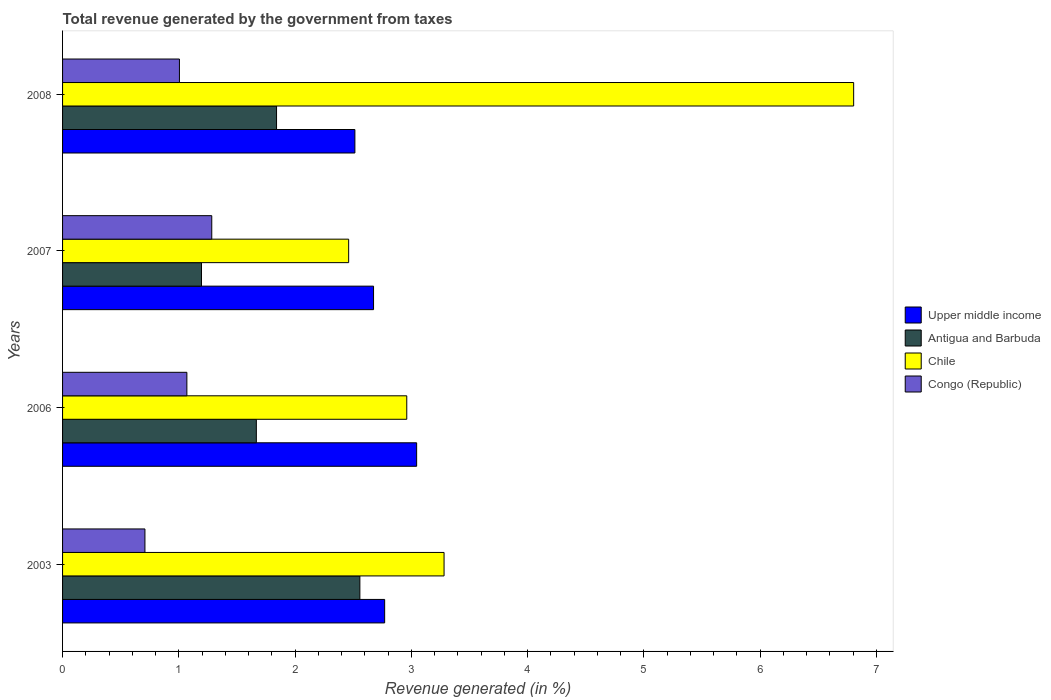How many different coloured bars are there?
Your response must be concise. 4. How many groups of bars are there?
Keep it short and to the point. 4. Are the number of bars on each tick of the Y-axis equal?
Offer a terse response. Yes. How many bars are there on the 3rd tick from the top?
Your response must be concise. 4. How many bars are there on the 3rd tick from the bottom?
Give a very brief answer. 4. What is the label of the 2nd group of bars from the top?
Ensure brevity in your answer.  2007. In how many cases, is the number of bars for a given year not equal to the number of legend labels?
Your response must be concise. 0. What is the total revenue generated in Congo (Republic) in 2006?
Your answer should be very brief. 1.07. Across all years, what is the maximum total revenue generated in Congo (Republic)?
Your answer should be very brief. 1.28. Across all years, what is the minimum total revenue generated in Chile?
Provide a succinct answer. 2.46. In which year was the total revenue generated in Upper middle income minimum?
Your response must be concise. 2008. What is the total total revenue generated in Chile in the graph?
Keep it short and to the point. 15.51. What is the difference between the total revenue generated in Chile in 2003 and that in 2007?
Make the answer very short. 0.82. What is the difference between the total revenue generated in Congo (Republic) in 2006 and the total revenue generated in Chile in 2003?
Ensure brevity in your answer.  -2.21. What is the average total revenue generated in Chile per year?
Offer a terse response. 3.88. In the year 2003, what is the difference between the total revenue generated in Antigua and Barbuda and total revenue generated in Congo (Republic)?
Provide a succinct answer. 1.85. In how many years, is the total revenue generated in Upper middle income greater than 4.8 %?
Offer a terse response. 0. What is the ratio of the total revenue generated in Antigua and Barbuda in 2007 to that in 2008?
Keep it short and to the point. 0.65. Is the total revenue generated in Congo (Republic) in 2006 less than that in 2007?
Offer a very short reply. Yes. Is the difference between the total revenue generated in Antigua and Barbuda in 2003 and 2007 greater than the difference between the total revenue generated in Congo (Republic) in 2003 and 2007?
Ensure brevity in your answer.  Yes. What is the difference between the highest and the second highest total revenue generated in Upper middle income?
Your answer should be compact. 0.28. What is the difference between the highest and the lowest total revenue generated in Upper middle income?
Your answer should be compact. 0.53. Is it the case that in every year, the sum of the total revenue generated in Antigua and Barbuda and total revenue generated in Upper middle income is greater than the sum of total revenue generated in Chile and total revenue generated in Congo (Republic)?
Provide a succinct answer. Yes. What does the 4th bar from the top in 2003 represents?
Provide a succinct answer. Upper middle income. What does the 1st bar from the bottom in 2007 represents?
Ensure brevity in your answer.  Upper middle income. Is it the case that in every year, the sum of the total revenue generated in Chile and total revenue generated in Antigua and Barbuda is greater than the total revenue generated in Congo (Republic)?
Your answer should be very brief. Yes. How many bars are there?
Offer a very short reply. 16. Are all the bars in the graph horizontal?
Keep it short and to the point. Yes. How many years are there in the graph?
Provide a succinct answer. 4. Are the values on the major ticks of X-axis written in scientific E-notation?
Offer a very short reply. No. Does the graph contain any zero values?
Your answer should be compact. No. Does the graph contain grids?
Ensure brevity in your answer.  No. How many legend labels are there?
Provide a short and direct response. 4. How are the legend labels stacked?
Your response must be concise. Vertical. What is the title of the graph?
Offer a terse response. Total revenue generated by the government from taxes. What is the label or title of the X-axis?
Make the answer very short. Revenue generated (in %). What is the label or title of the Y-axis?
Make the answer very short. Years. What is the Revenue generated (in %) of Upper middle income in 2003?
Your answer should be very brief. 2.77. What is the Revenue generated (in %) in Antigua and Barbuda in 2003?
Ensure brevity in your answer.  2.56. What is the Revenue generated (in %) of Chile in 2003?
Offer a terse response. 3.28. What is the Revenue generated (in %) of Congo (Republic) in 2003?
Provide a succinct answer. 0.71. What is the Revenue generated (in %) in Upper middle income in 2006?
Keep it short and to the point. 3.05. What is the Revenue generated (in %) of Antigua and Barbuda in 2006?
Offer a very short reply. 1.67. What is the Revenue generated (in %) in Chile in 2006?
Your response must be concise. 2.96. What is the Revenue generated (in %) in Congo (Republic) in 2006?
Provide a succinct answer. 1.07. What is the Revenue generated (in %) of Upper middle income in 2007?
Your answer should be compact. 2.68. What is the Revenue generated (in %) in Antigua and Barbuda in 2007?
Your response must be concise. 1.2. What is the Revenue generated (in %) in Chile in 2007?
Provide a succinct answer. 2.46. What is the Revenue generated (in %) in Congo (Republic) in 2007?
Your answer should be compact. 1.28. What is the Revenue generated (in %) of Upper middle income in 2008?
Keep it short and to the point. 2.51. What is the Revenue generated (in %) of Antigua and Barbuda in 2008?
Give a very brief answer. 1.84. What is the Revenue generated (in %) of Chile in 2008?
Give a very brief answer. 6.81. What is the Revenue generated (in %) of Congo (Republic) in 2008?
Provide a short and direct response. 1.01. Across all years, what is the maximum Revenue generated (in %) of Upper middle income?
Offer a very short reply. 3.05. Across all years, what is the maximum Revenue generated (in %) in Antigua and Barbuda?
Provide a short and direct response. 2.56. Across all years, what is the maximum Revenue generated (in %) in Chile?
Your response must be concise. 6.81. Across all years, what is the maximum Revenue generated (in %) of Congo (Republic)?
Offer a very short reply. 1.28. Across all years, what is the minimum Revenue generated (in %) of Upper middle income?
Your answer should be very brief. 2.51. Across all years, what is the minimum Revenue generated (in %) in Antigua and Barbuda?
Make the answer very short. 1.2. Across all years, what is the minimum Revenue generated (in %) in Chile?
Your answer should be very brief. 2.46. Across all years, what is the minimum Revenue generated (in %) of Congo (Republic)?
Ensure brevity in your answer.  0.71. What is the total Revenue generated (in %) in Upper middle income in the graph?
Offer a terse response. 11.01. What is the total Revenue generated (in %) of Antigua and Barbuda in the graph?
Make the answer very short. 7.26. What is the total Revenue generated (in %) of Chile in the graph?
Make the answer very short. 15.51. What is the total Revenue generated (in %) in Congo (Republic) in the graph?
Your answer should be very brief. 4.07. What is the difference between the Revenue generated (in %) of Upper middle income in 2003 and that in 2006?
Ensure brevity in your answer.  -0.28. What is the difference between the Revenue generated (in %) in Antigua and Barbuda in 2003 and that in 2006?
Offer a terse response. 0.89. What is the difference between the Revenue generated (in %) of Chile in 2003 and that in 2006?
Your answer should be compact. 0.32. What is the difference between the Revenue generated (in %) of Congo (Republic) in 2003 and that in 2006?
Give a very brief answer. -0.36. What is the difference between the Revenue generated (in %) in Upper middle income in 2003 and that in 2007?
Ensure brevity in your answer.  0.1. What is the difference between the Revenue generated (in %) of Antigua and Barbuda in 2003 and that in 2007?
Your answer should be very brief. 1.36. What is the difference between the Revenue generated (in %) in Chile in 2003 and that in 2007?
Keep it short and to the point. 0.82. What is the difference between the Revenue generated (in %) of Congo (Republic) in 2003 and that in 2007?
Keep it short and to the point. -0.57. What is the difference between the Revenue generated (in %) in Upper middle income in 2003 and that in 2008?
Offer a very short reply. 0.26. What is the difference between the Revenue generated (in %) in Antigua and Barbuda in 2003 and that in 2008?
Keep it short and to the point. 0.72. What is the difference between the Revenue generated (in %) in Chile in 2003 and that in 2008?
Your response must be concise. -3.52. What is the difference between the Revenue generated (in %) in Congo (Republic) in 2003 and that in 2008?
Keep it short and to the point. -0.3. What is the difference between the Revenue generated (in %) of Upper middle income in 2006 and that in 2007?
Your answer should be compact. 0.37. What is the difference between the Revenue generated (in %) of Antigua and Barbuda in 2006 and that in 2007?
Offer a terse response. 0.47. What is the difference between the Revenue generated (in %) of Chile in 2006 and that in 2007?
Offer a terse response. 0.5. What is the difference between the Revenue generated (in %) of Congo (Republic) in 2006 and that in 2007?
Your answer should be very brief. -0.21. What is the difference between the Revenue generated (in %) in Upper middle income in 2006 and that in 2008?
Your answer should be compact. 0.53. What is the difference between the Revenue generated (in %) in Antigua and Barbuda in 2006 and that in 2008?
Provide a short and direct response. -0.17. What is the difference between the Revenue generated (in %) in Chile in 2006 and that in 2008?
Keep it short and to the point. -3.84. What is the difference between the Revenue generated (in %) of Congo (Republic) in 2006 and that in 2008?
Your answer should be compact. 0.06. What is the difference between the Revenue generated (in %) of Upper middle income in 2007 and that in 2008?
Keep it short and to the point. 0.16. What is the difference between the Revenue generated (in %) of Antigua and Barbuda in 2007 and that in 2008?
Your answer should be very brief. -0.65. What is the difference between the Revenue generated (in %) of Chile in 2007 and that in 2008?
Offer a very short reply. -4.34. What is the difference between the Revenue generated (in %) of Congo (Republic) in 2007 and that in 2008?
Your response must be concise. 0.28. What is the difference between the Revenue generated (in %) of Upper middle income in 2003 and the Revenue generated (in %) of Antigua and Barbuda in 2006?
Provide a succinct answer. 1.1. What is the difference between the Revenue generated (in %) in Upper middle income in 2003 and the Revenue generated (in %) in Chile in 2006?
Give a very brief answer. -0.19. What is the difference between the Revenue generated (in %) in Upper middle income in 2003 and the Revenue generated (in %) in Congo (Republic) in 2006?
Keep it short and to the point. 1.7. What is the difference between the Revenue generated (in %) of Antigua and Barbuda in 2003 and the Revenue generated (in %) of Chile in 2006?
Provide a succinct answer. -0.4. What is the difference between the Revenue generated (in %) in Antigua and Barbuda in 2003 and the Revenue generated (in %) in Congo (Republic) in 2006?
Provide a succinct answer. 1.49. What is the difference between the Revenue generated (in %) of Chile in 2003 and the Revenue generated (in %) of Congo (Republic) in 2006?
Provide a succinct answer. 2.21. What is the difference between the Revenue generated (in %) of Upper middle income in 2003 and the Revenue generated (in %) of Antigua and Barbuda in 2007?
Give a very brief answer. 1.58. What is the difference between the Revenue generated (in %) in Upper middle income in 2003 and the Revenue generated (in %) in Chile in 2007?
Your answer should be very brief. 0.31. What is the difference between the Revenue generated (in %) in Upper middle income in 2003 and the Revenue generated (in %) in Congo (Republic) in 2007?
Your response must be concise. 1.49. What is the difference between the Revenue generated (in %) of Antigua and Barbuda in 2003 and the Revenue generated (in %) of Chile in 2007?
Offer a very short reply. 0.1. What is the difference between the Revenue generated (in %) of Antigua and Barbuda in 2003 and the Revenue generated (in %) of Congo (Republic) in 2007?
Keep it short and to the point. 1.27. What is the difference between the Revenue generated (in %) of Chile in 2003 and the Revenue generated (in %) of Congo (Republic) in 2007?
Provide a short and direct response. 2. What is the difference between the Revenue generated (in %) in Upper middle income in 2003 and the Revenue generated (in %) in Antigua and Barbuda in 2008?
Offer a very short reply. 0.93. What is the difference between the Revenue generated (in %) in Upper middle income in 2003 and the Revenue generated (in %) in Chile in 2008?
Your response must be concise. -4.03. What is the difference between the Revenue generated (in %) in Upper middle income in 2003 and the Revenue generated (in %) in Congo (Republic) in 2008?
Provide a short and direct response. 1.77. What is the difference between the Revenue generated (in %) of Antigua and Barbuda in 2003 and the Revenue generated (in %) of Chile in 2008?
Ensure brevity in your answer.  -4.25. What is the difference between the Revenue generated (in %) of Antigua and Barbuda in 2003 and the Revenue generated (in %) of Congo (Republic) in 2008?
Your response must be concise. 1.55. What is the difference between the Revenue generated (in %) in Chile in 2003 and the Revenue generated (in %) in Congo (Republic) in 2008?
Keep it short and to the point. 2.28. What is the difference between the Revenue generated (in %) of Upper middle income in 2006 and the Revenue generated (in %) of Antigua and Barbuda in 2007?
Provide a succinct answer. 1.85. What is the difference between the Revenue generated (in %) of Upper middle income in 2006 and the Revenue generated (in %) of Chile in 2007?
Provide a succinct answer. 0.58. What is the difference between the Revenue generated (in %) of Upper middle income in 2006 and the Revenue generated (in %) of Congo (Republic) in 2007?
Ensure brevity in your answer.  1.76. What is the difference between the Revenue generated (in %) in Antigua and Barbuda in 2006 and the Revenue generated (in %) in Chile in 2007?
Keep it short and to the point. -0.79. What is the difference between the Revenue generated (in %) in Antigua and Barbuda in 2006 and the Revenue generated (in %) in Congo (Republic) in 2007?
Offer a terse response. 0.38. What is the difference between the Revenue generated (in %) in Chile in 2006 and the Revenue generated (in %) in Congo (Republic) in 2007?
Keep it short and to the point. 1.68. What is the difference between the Revenue generated (in %) of Upper middle income in 2006 and the Revenue generated (in %) of Antigua and Barbuda in 2008?
Ensure brevity in your answer.  1.21. What is the difference between the Revenue generated (in %) in Upper middle income in 2006 and the Revenue generated (in %) in Chile in 2008?
Give a very brief answer. -3.76. What is the difference between the Revenue generated (in %) of Upper middle income in 2006 and the Revenue generated (in %) of Congo (Republic) in 2008?
Provide a succinct answer. 2.04. What is the difference between the Revenue generated (in %) in Antigua and Barbuda in 2006 and the Revenue generated (in %) in Chile in 2008?
Offer a terse response. -5.14. What is the difference between the Revenue generated (in %) of Antigua and Barbuda in 2006 and the Revenue generated (in %) of Congo (Republic) in 2008?
Keep it short and to the point. 0.66. What is the difference between the Revenue generated (in %) of Chile in 2006 and the Revenue generated (in %) of Congo (Republic) in 2008?
Keep it short and to the point. 1.96. What is the difference between the Revenue generated (in %) of Upper middle income in 2007 and the Revenue generated (in %) of Antigua and Barbuda in 2008?
Ensure brevity in your answer.  0.83. What is the difference between the Revenue generated (in %) in Upper middle income in 2007 and the Revenue generated (in %) in Chile in 2008?
Ensure brevity in your answer.  -4.13. What is the difference between the Revenue generated (in %) of Upper middle income in 2007 and the Revenue generated (in %) of Congo (Republic) in 2008?
Your answer should be compact. 1.67. What is the difference between the Revenue generated (in %) of Antigua and Barbuda in 2007 and the Revenue generated (in %) of Chile in 2008?
Your answer should be compact. -5.61. What is the difference between the Revenue generated (in %) in Antigua and Barbuda in 2007 and the Revenue generated (in %) in Congo (Republic) in 2008?
Provide a short and direct response. 0.19. What is the difference between the Revenue generated (in %) of Chile in 2007 and the Revenue generated (in %) of Congo (Republic) in 2008?
Provide a succinct answer. 1.46. What is the average Revenue generated (in %) in Upper middle income per year?
Your response must be concise. 2.75. What is the average Revenue generated (in %) in Antigua and Barbuda per year?
Ensure brevity in your answer.  1.82. What is the average Revenue generated (in %) of Chile per year?
Provide a short and direct response. 3.88. What is the average Revenue generated (in %) of Congo (Republic) per year?
Offer a very short reply. 1.02. In the year 2003, what is the difference between the Revenue generated (in %) in Upper middle income and Revenue generated (in %) in Antigua and Barbuda?
Offer a very short reply. 0.21. In the year 2003, what is the difference between the Revenue generated (in %) in Upper middle income and Revenue generated (in %) in Chile?
Offer a very short reply. -0.51. In the year 2003, what is the difference between the Revenue generated (in %) in Upper middle income and Revenue generated (in %) in Congo (Republic)?
Provide a short and direct response. 2.06. In the year 2003, what is the difference between the Revenue generated (in %) in Antigua and Barbuda and Revenue generated (in %) in Chile?
Offer a terse response. -0.72. In the year 2003, what is the difference between the Revenue generated (in %) of Antigua and Barbuda and Revenue generated (in %) of Congo (Republic)?
Your answer should be very brief. 1.85. In the year 2003, what is the difference between the Revenue generated (in %) of Chile and Revenue generated (in %) of Congo (Republic)?
Give a very brief answer. 2.57. In the year 2006, what is the difference between the Revenue generated (in %) in Upper middle income and Revenue generated (in %) in Antigua and Barbuda?
Give a very brief answer. 1.38. In the year 2006, what is the difference between the Revenue generated (in %) in Upper middle income and Revenue generated (in %) in Chile?
Ensure brevity in your answer.  0.09. In the year 2006, what is the difference between the Revenue generated (in %) in Upper middle income and Revenue generated (in %) in Congo (Republic)?
Your answer should be compact. 1.98. In the year 2006, what is the difference between the Revenue generated (in %) in Antigua and Barbuda and Revenue generated (in %) in Chile?
Your response must be concise. -1.29. In the year 2006, what is the difference between the Revenue generated (in %) of Antigua and Barbuda and Revenue generated (in %) of Congo (Republic)?
Your answer should be compact. 0.6. In the year 2006, what is the difference between the Revenue generated (in %) in Chile and Revenue generated (in %) in Congo (Republic)?
Offer a terse response. 1.89. In the year 2007, what is the difference between the Revenue generated (in %) in Upper middle income and Revenue generated (in %) in Antigua and Barbuda?
Provide a short and direct response. 1.48. In the year 2007, what is the difference between the Revenue generated (in %) of Upper middle income and Revenue generated (in %) of Chile?
Ensure brevity in your answer.  0.21. In the year 2007, what is the difference between the Revenue generated (in %) in Upper middle income and Revenue generated (in %) in Congo (Republic)?
Offer a terse response. 1.39. In the year 2007, what is the difference between the Revenue generated (in %) of Antigua and Barbuda and Revenue generated (in %) of Chile?
Offer a very short reply. -1.27. In the year 2007, what is the difference between the Revenue generated (in %) in Antigua and Barbuda and Revenue generated (in %) in Congo (Republic)?
Keep it short and to the point. -0.09. In the year 2007, what is the difference between the Revenue generated (in %) in Chile and Revenue generated (in %) in Congo (Republic)?
Offer a very short reply. 1.18. In the year 2008, what is the difference between the Revenue generated (in %) of Upper middle income and Revenue generated (in %) of Antigua and Barbuda?
Your response must be concise. 0.67. In the year 2008, what is the difference between the Revenue generated (in %) of Upper middle income and Revenue generated (in %) of Chile?
Keep it short and to the point. -4.29. In the year 2008, what is the difference between the Revenue generated (in %) of Upper middle income and Revenue generated (in %) of Congo (Republic)?
Provide a succinct answer. 1.51. In the year 2008, what is the difference between the Revenue generated (in %) of Antigua and Barbuda and Revenue generated (in %) of Chile?
Your answer should be very brief. -4.96. In the year 2008, what is the difference between the Revenue generated (in %) of Antigua and Barbuda and Revenue generated (in %) of Congo (Republic)?
Offer a very short reply. 0.84. In the year 2008, what is the difference between the Revenue generated (in %) of Chile and Revenue generated (in %) of Congo (Republic)?
Your answer should be very brief. 5.8. What is the ratio of the Revenue generated (in %) in Upper middle income in 2003 to that in 2006?
Make the answer very short. 0.91. What is the ratio of the Revenue generated (in %) of Antigua and Barbuda in 2003 to that in 2006?
Offer a terse response. 1.53. What is the ratio of the Revenue generated (in %) in Chile in 2003 to that in 2006?
Your response must be concise. 1.11. What is the ratio of the Revenue generated (in %) of Congo (Republic) in 2003 to that in 2006?
Keep it short and to the point. 0.66. What is the ratio of the Revenue generated (in %) in Upper middle income in 2003 to that in 2007?
Give a very brief answer. 1.04. What is the ratio of the Revenue generated (in %) of Antigua and Barbuda in 2003 to that in 2007?
Your answer should be compact. 2.14. What is the ratio of the Revenue generated (in %) of Chile in 2003 to that in 2007?
Ensure brevity in your answer.  1.33. What is the ratio of the Revenue generated (in %) of Congo (Republic) in 2003 to that in 2007?
Keep it short and to the point. 0.55. What is the ratio of the Revenue generated (in %) of Upper middle income in 2003 to that in 2008?
Provide a short and direct response. 1.1. What is the ratio of the Revenue generated (in %) of Antigua and Barbuda in 2003 to that in 2008?
Provide a short and direct response. 1.39. What is the ratio of the Revenue generated (in %) in Chile in 2003 to that in 2008?
Give a very brief answer. 0.48. What is the ratio of the Revenue generated (in %) in Congo (Republic) in 2003 to that in 2008?
Give a very brief answer. 0.7. What is the ratio of the Revenue generated (in %) in Upper middle income in 2006 to that in 2007?
Offer a very short reply. 1.14. What is the ratio of the Revenue generated (in %) of Antigua and Barbuda in 2006 to that in 2007?
Your response must be concise. 1.39. What is the ratio of the Revenue generated (in %) of Chile in 2006 to that in 2007?
Give a very brief answer. 1.2. What is the ratio of the Revenue generated (in %) in Congo (Republic) in 2006 to that in 2007?
Keep it short and to the point. 0.83. What is the ratio of the Revenue generated (in %) in Upper middle income in 2006 to that in 2008?
Your answer should be very brief. 1.21. What is the ratio of the Revenue generated (in %) in Antigua and Barbuda in 2006 to that in 2008?
Make the answer very short. 0.91. What is the ratio of the Revenue generated (in %) in Chile in 2006 to that in 2008?
Your response must be concise. 0.44. What is the ratio of the Revenue generated (in %) of Congo (Republic) in 2006 to that in 2008?
Provide a succinct answer. 1.06. What is the ratio of the Revenue generated (in %) of Upper middle income in 2007 to that in 2008?
Make the answer very short. 1.06. What is the ratio of the Revenue generated (in %) in Antigua and Barbuda in 2007 to that in 2008?
Your answer should be compact. 0.65. What is the ratio of the Revenue generated (in %) of Chile in 2007 to that in 2008?
Offer a very short reply. 0.36. What is the ratio of the Revenue generated (in %) of Congo (Republic) in 2007 to that in 2008?
Offer a terse response. 1.28. What is the difference between the highest and the second highest Revenue generated (in %) in Upper middle income?
Offer a very short reply. 0.28. What is the difference between the highest and the second highest Revenue generated (in %) of Antigua and Barbuda?
Your answer should be very brief. 0.72. What is the difference between the highest and the second highest Revenue generated (in %) of Chile?
Give a very brief answer. 3.52. What is the difference between the highest and the second highest Revenue generated (in %) in Congo (Republic)?
Your answer should be very brief. 0.21. What is the difference between the highest and the lowest Revenue generated (in %) in Upper middle income?
Make the answer very short. 0.53. What is the difference between the highest and the lowest Revenue generated (in %) in Antigua and Barbuda?
Your response must be concise. 1.36. What is the difference between the highest and the lowest Revenue generated (in %) of Chile?
Ensure brevity in your answer.  4.34. What is the difference between the highest and the lowest Revenue generated (in %) in Congo (Republic)?
Your answer should be very brief. 0.57. 